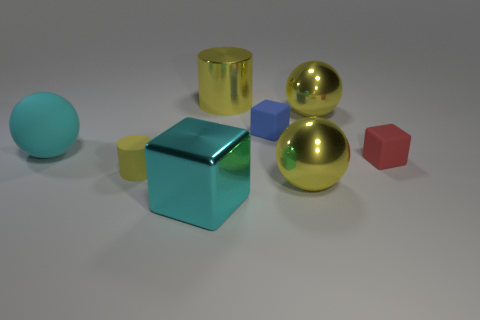Is there any other thing that is the same size as the metal block?
Ensure brevity in your answer.  Yes. How many balls are gray matte objects or tiny rubber things?
Your answer should be very brief. 0. Does the red thing have the same material as the large cyan sphere?
Provide a short and direct response. Yes. What number of other objects are the same color as the large rubber thing?
Keep it short and to the point. 1. What is the shape of the big yellow object in front of the red rubber cube?
Your answer should be compact. Sphere. How many things are either purple metal things or small rubber cylinders?
Ensure brevity in your answer.  1. There is a red rubber cube; does it have the same size as the yellow object to the left of the big block?
Offer a terse response. Yes. How many other objects are the same material as the big cube?
Offer a very short reply. 3. What number of objects are either big metal things that are behind the small yellow cylinder or cyan things on the left side of the cyan block?
Your response must be concise. 3. What is the material of the small blue object that is the same shape as the tiny red object?
Ensure brevity in your answer.  Rubber. 